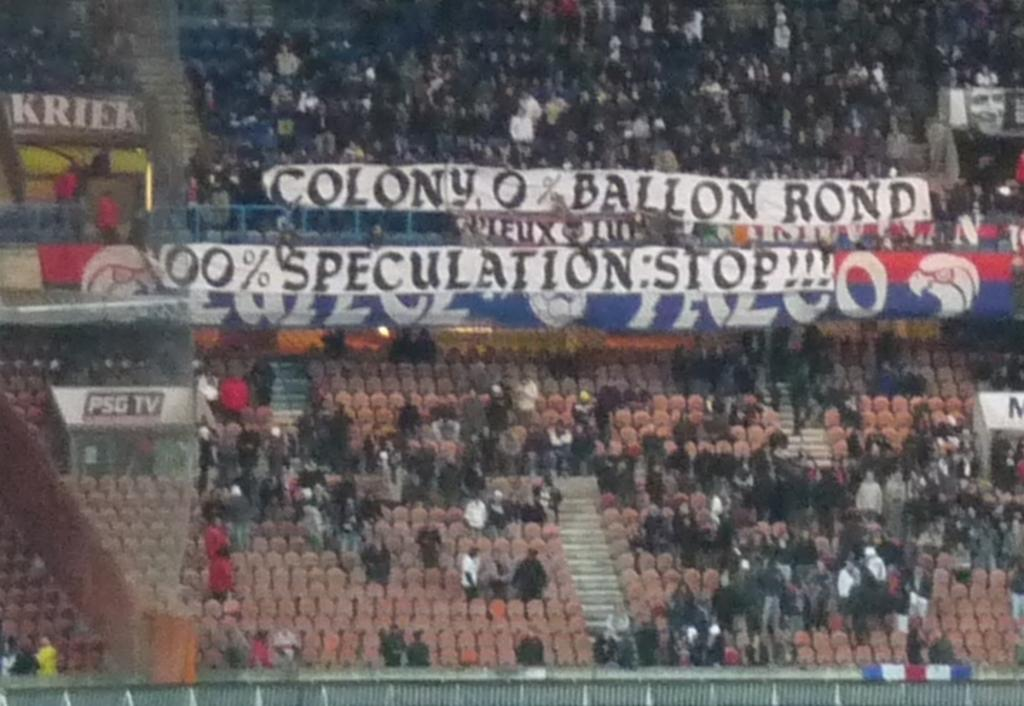Provide a one-sentence caption for the provided image. At a baseball game, people put up a sign that says "Colony, 0% Ballon Rond. 100% Speculation: Stop !!!". 